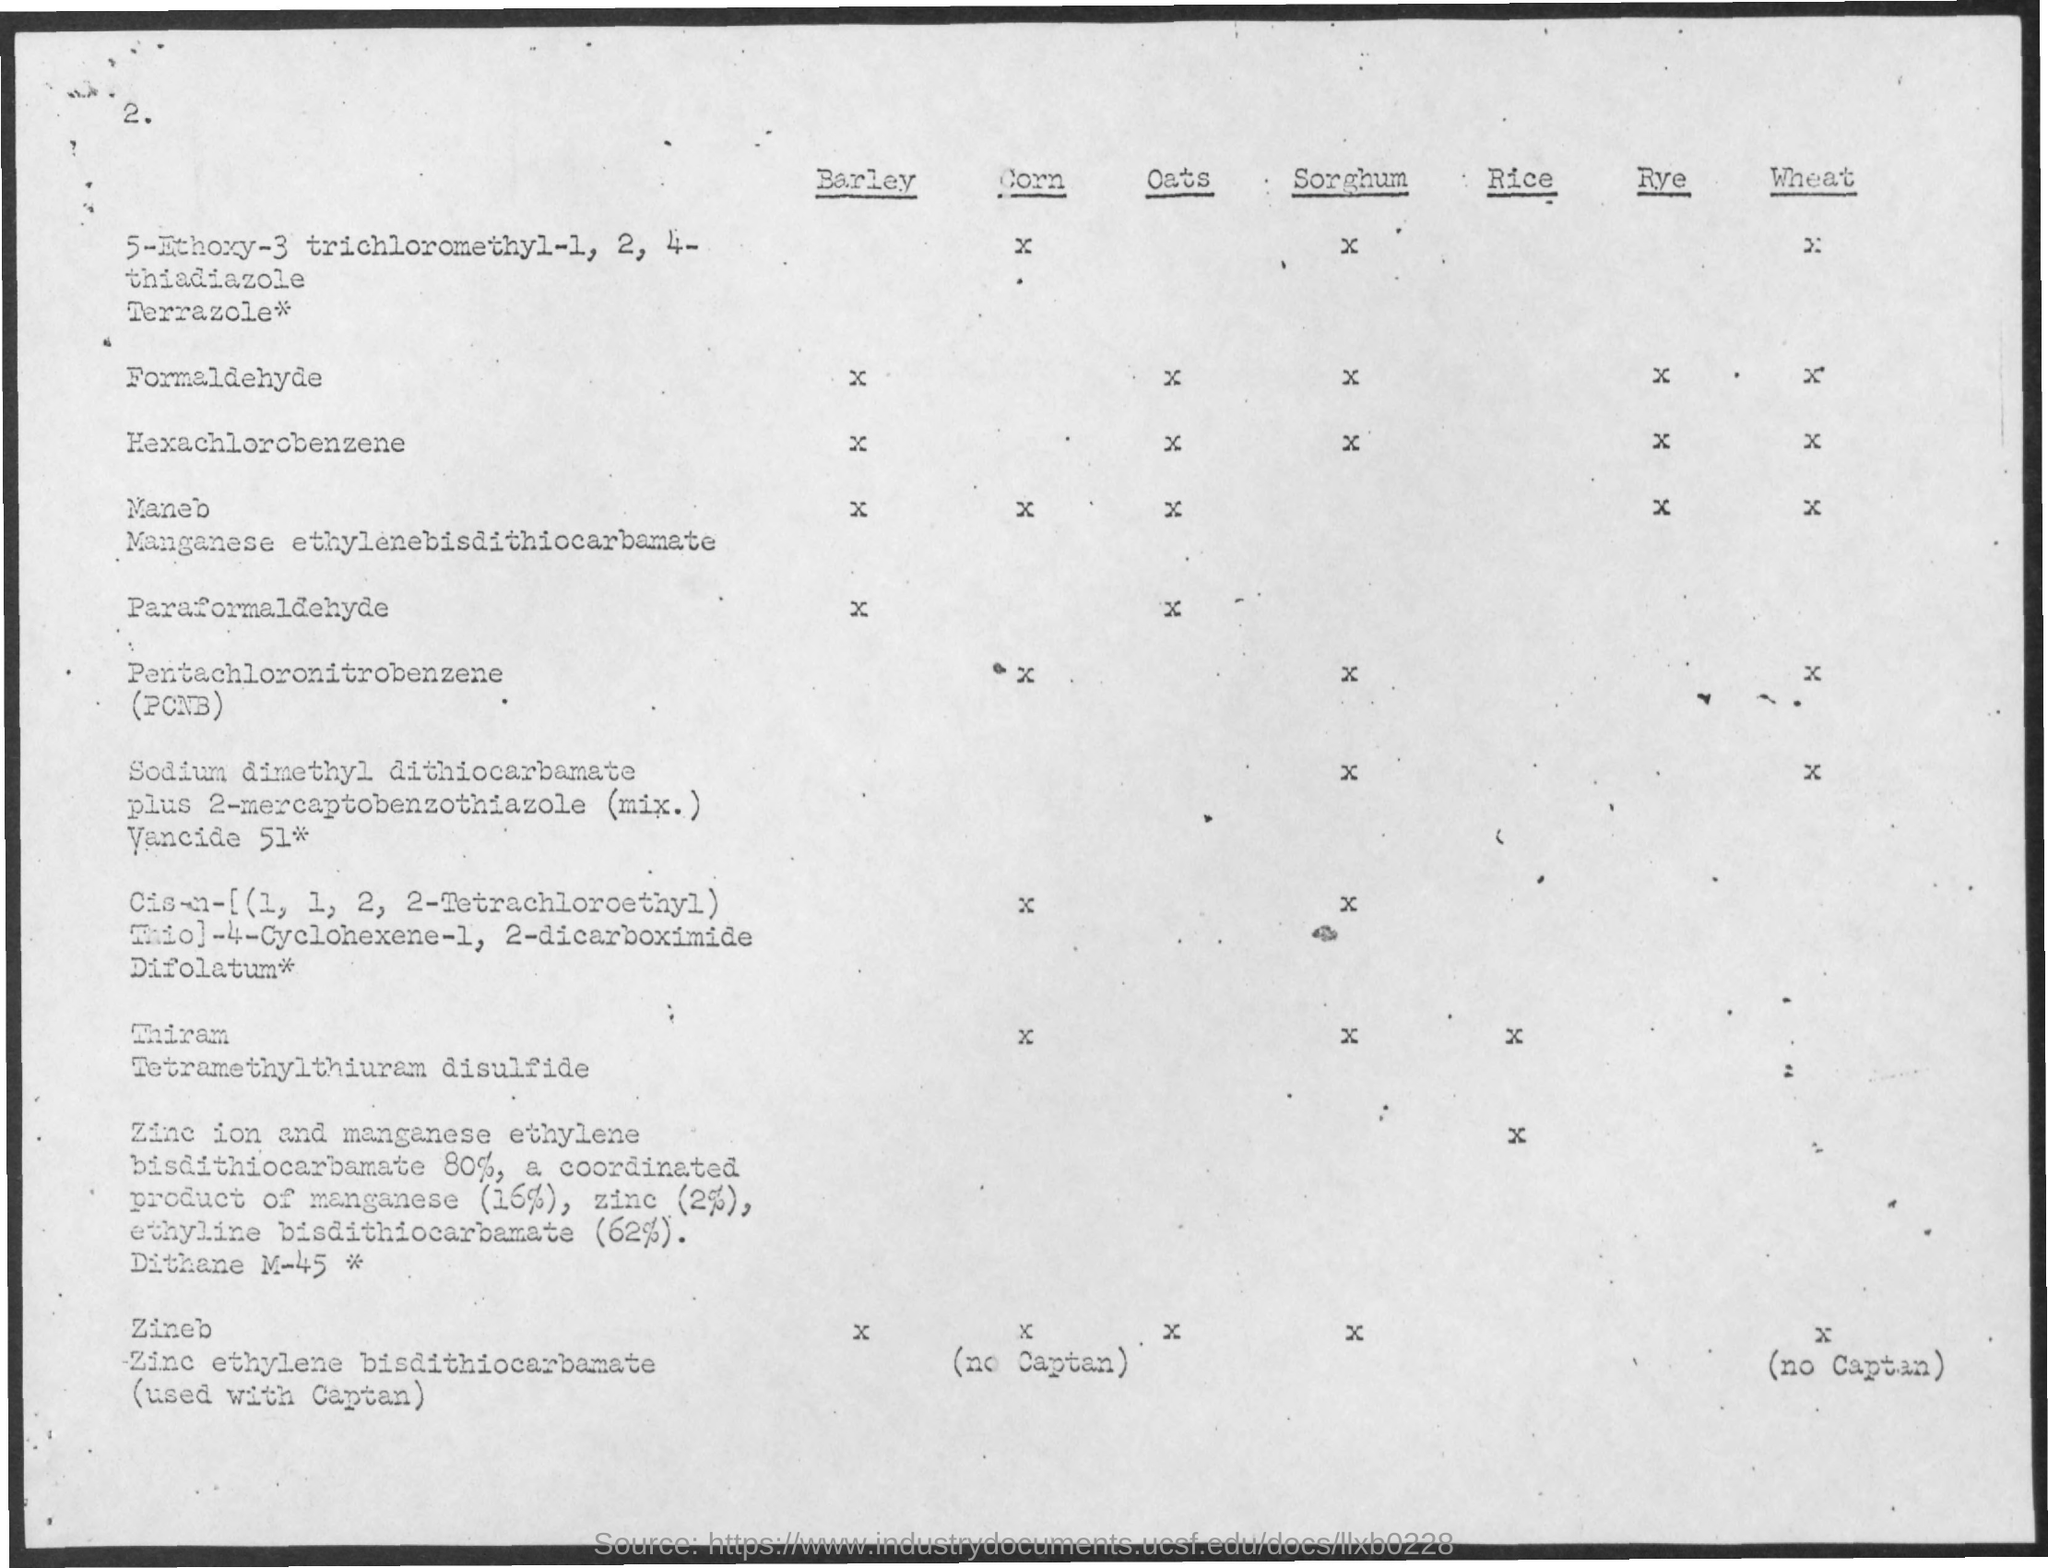What is the Page Number?
Ensure brevity in your answer.  2. 